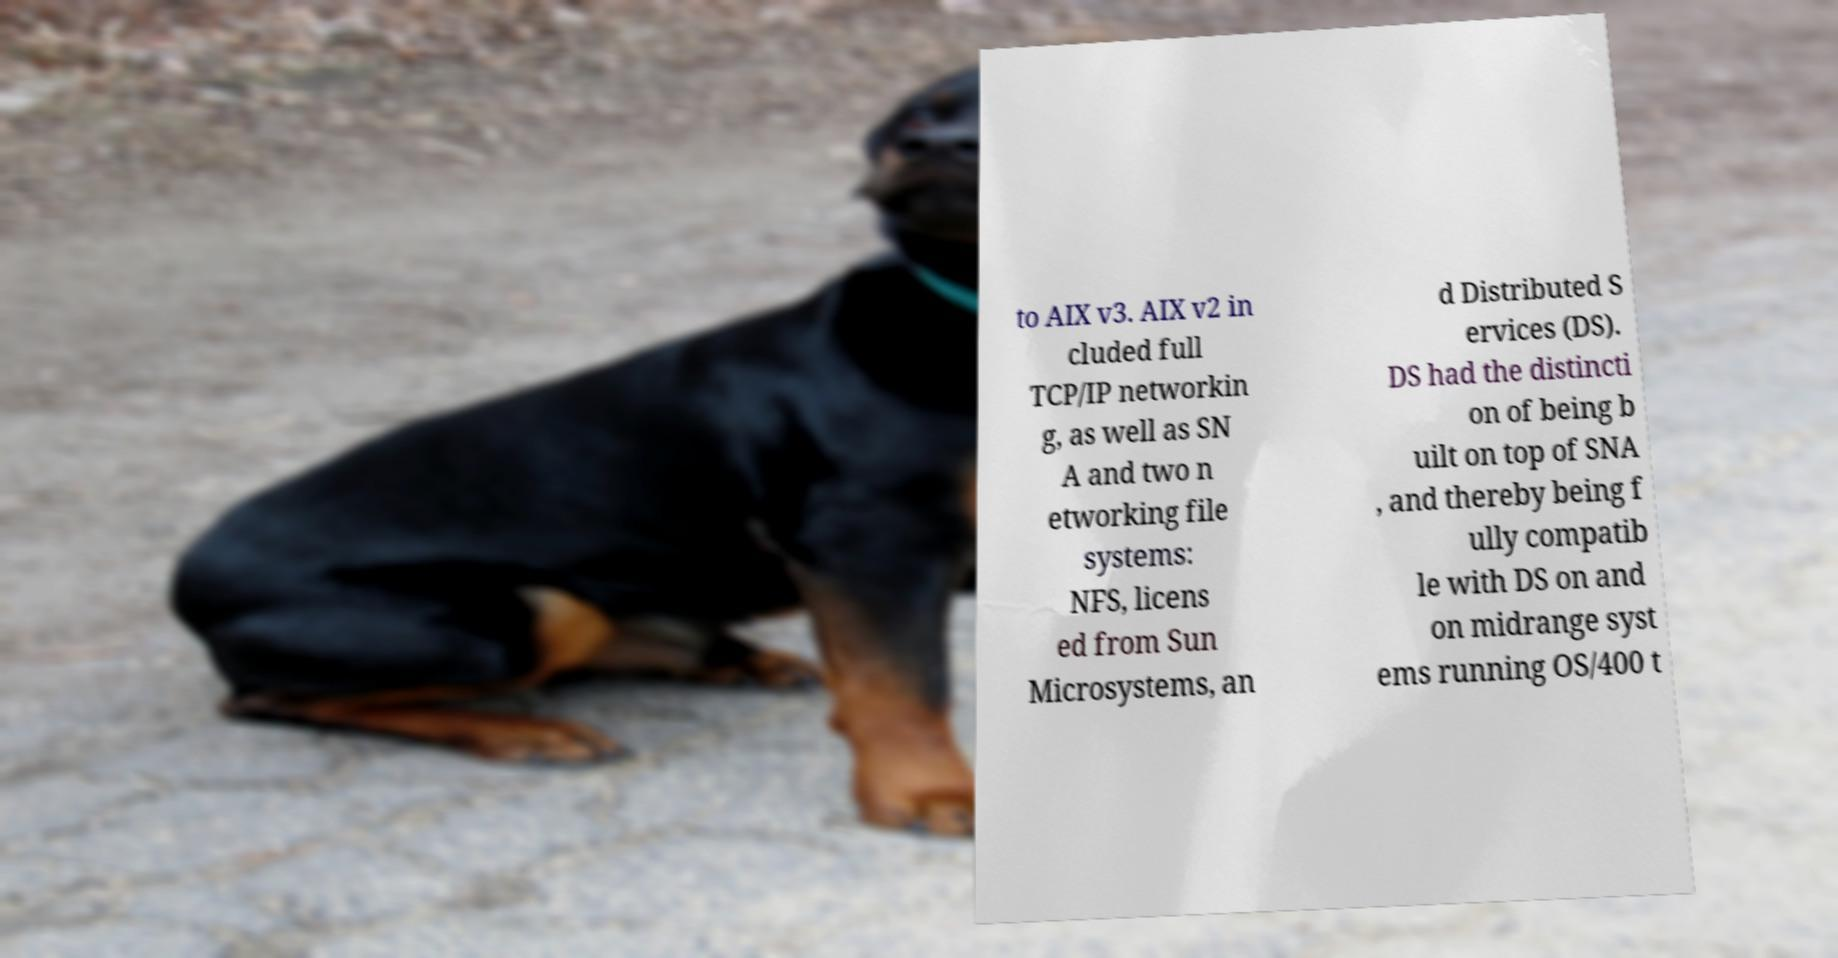Could you extract and type out the text from this image? to AIX v3. AIX v2 in cluded full TCP/IP networkin g, as well as SN A and two n etworking file systems: NFS, licens ed from Sun Microsystems, an d Distributed S ervices (DS). DS had the distincti on of being b uilt on top of SNA , and thereby being f ully compatib le with DS on and on midrange syst ems running OS/400 t 